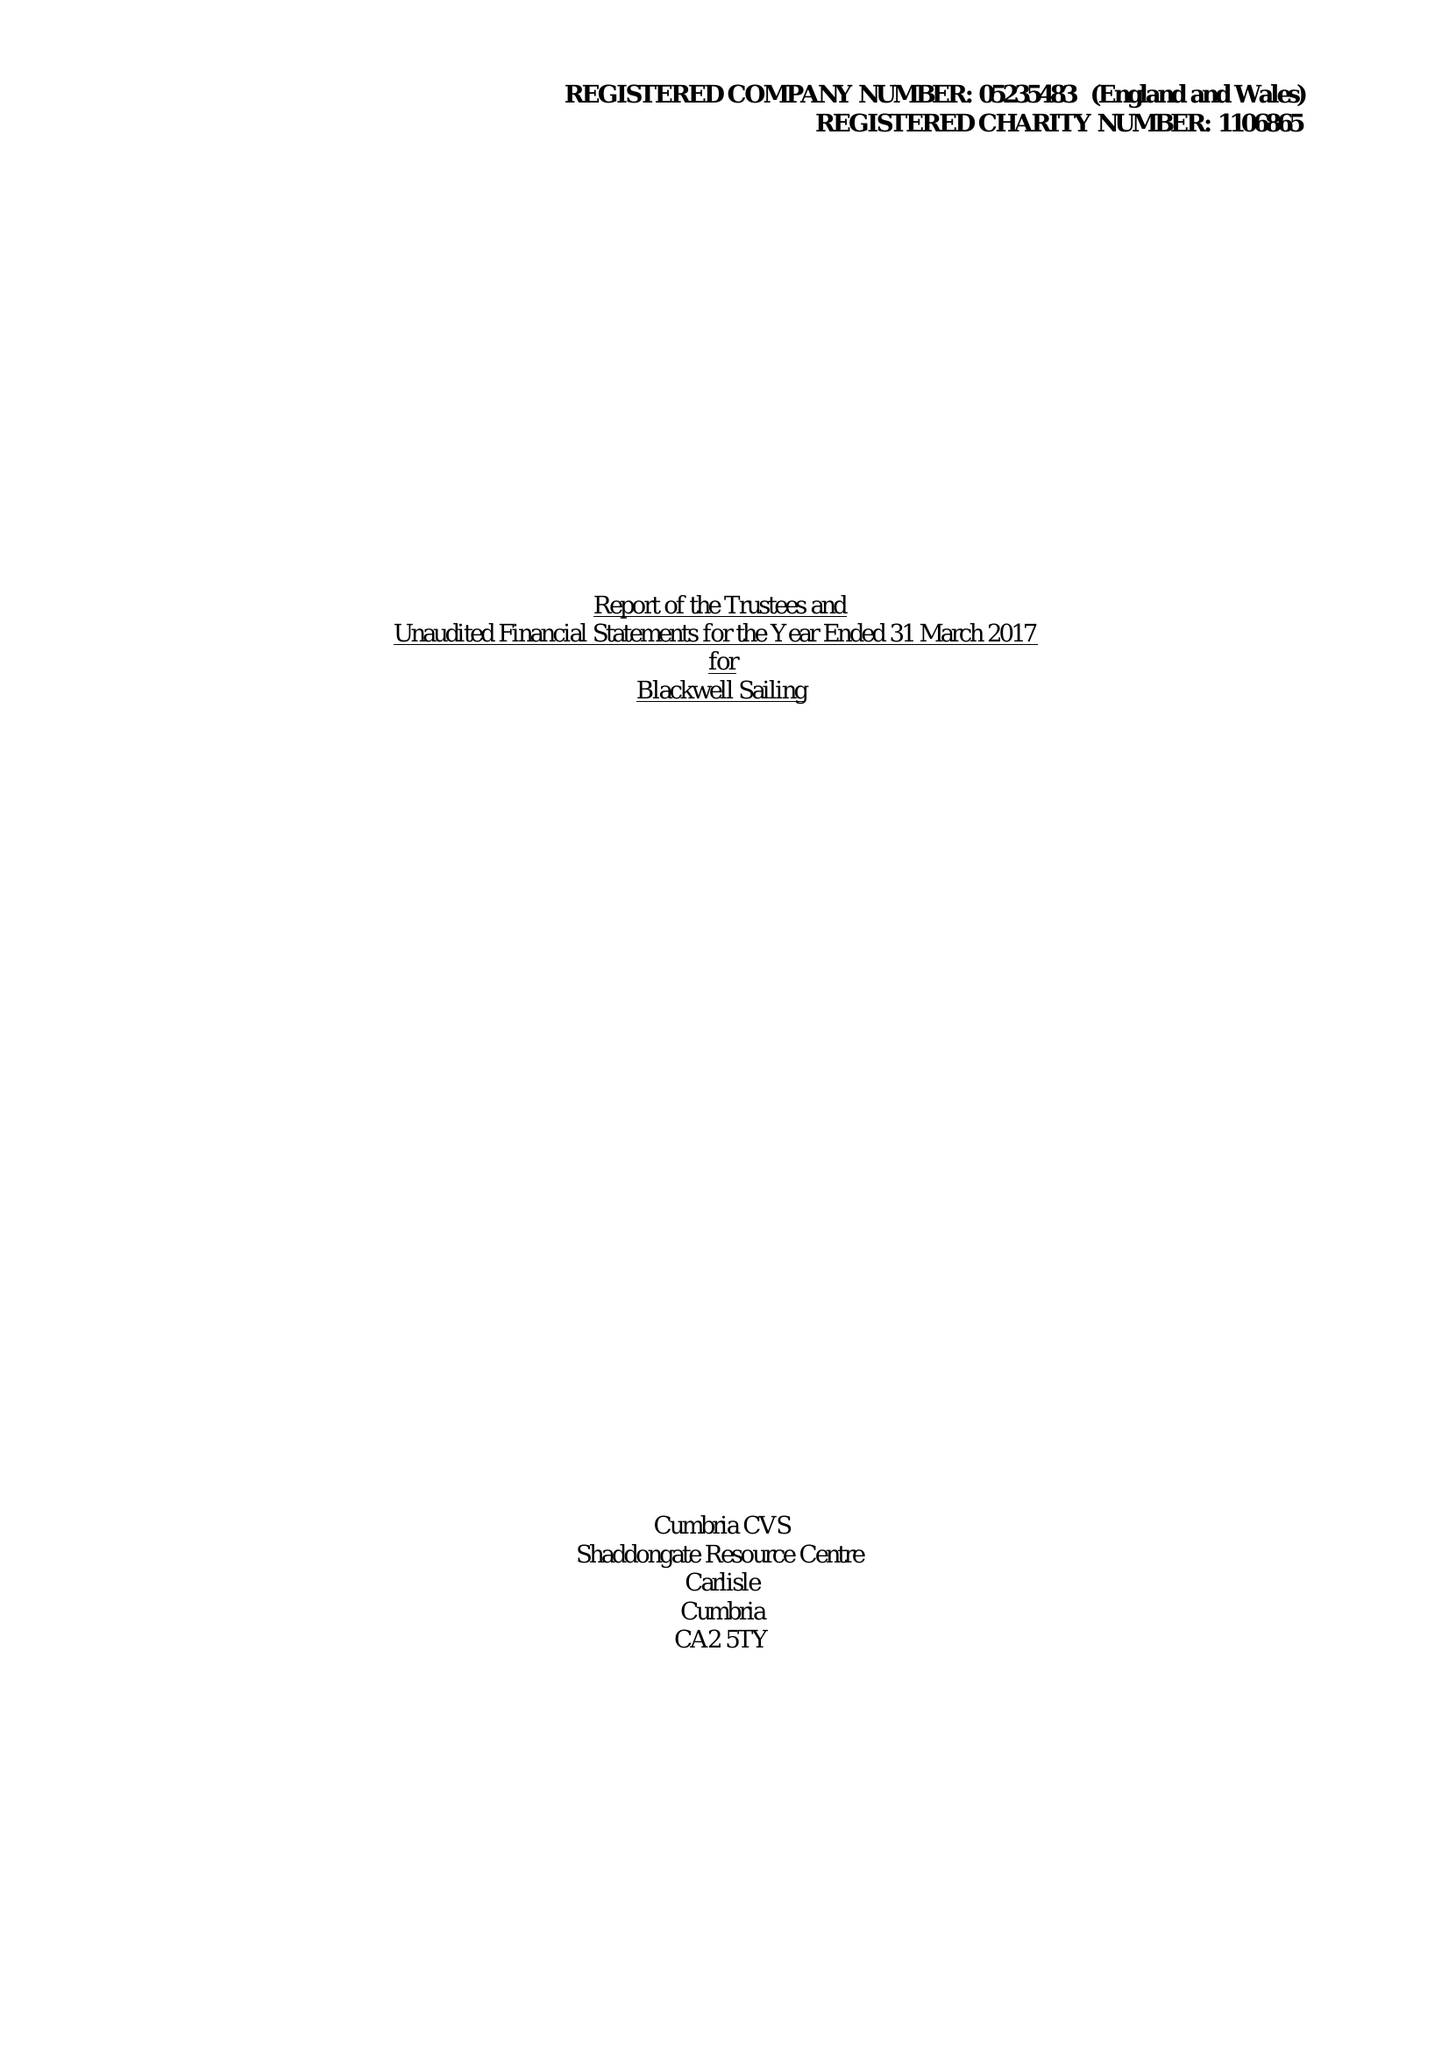What is the value for the charity_name?
Answer the question using a single word or phrase. Blackwell Sailing 